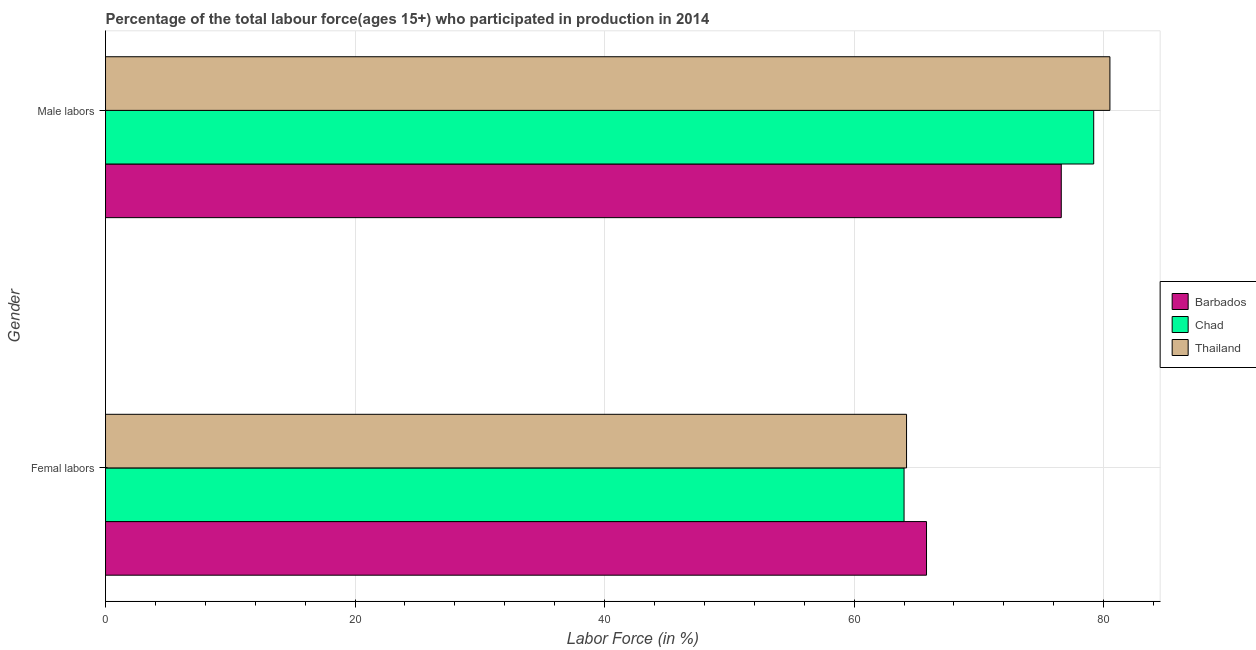How many groups of bars are there?
Your response must be concise. 2. Are the number of bars per tick equal to the number of legend labels?
Your answer should be very brief. Yes. Are the number of bars on each tick of the Y-axis equal?
Give a very brief answer. Yes. What is the label of the 1st group of bars from the top?
Your answer should be compact. Male labors. What is the percentage of male labour force in Thailand?
Your answer should be compact. 80.5. Across all countries, what is the maximum percentage of male labour force?
Give a very brief answer. 80.5. Across all countries, what is the minimum percentage of male labour force?
Keep it short and to the point. 76.6. In which country was the percentage of female labor force maximum?
Provide a succinct answer. Barbados. In which country was the percentage of female labor force minimum?
Keep it short and to the point. Chad. What is the total percentage of female labor force in the graph?
Your response must be concise. 194. What is the difference between the percentage of female labor force in Thailand and that in Barbados?
Ensure brevity in your answer.  -1.6. What is the difference between the percentage of female labor force in Chad and the percentage of male labour force in Barbados?
Your answer should be compact. -12.6. What is the average percentage of male labour force per country?
Your response must be concise. 78.77. What is the difference between the percentage of male labour force and percentage of female labor force in Barbados?
Provide a short and direct response. 10.8. In how many countries, is the percentage of male labour force greater than 76 %?
Give a very brief answer. 3. What is the ratio of the percentage of female labor force in Thailand to that in Chad?
Provide a short and direct response. 1. In how many countries, is the percentage of male labour force greater than the average percentage of male labour force taken over all countries?
Your response must be concise. 2. What does the 2nd bar from the top in Femal labors represents?
Offer a terse response. Chad. What does the 3rd bar from the bottom in Femal labors represents?
Make the answer very short. Thailand. How many bars are there?
Keep it short and to the point. 6. Are all the bars in the graph horizontal?
Make the answer very short. Yes. Are the values on the major ticks of X-axis written in scientific E-notation?
Your answer should be compact. No. How many legend labels are there?
Make the answer very short. 3. What is the title of the graph?
Provide a short and direct response. Percentage of the total labour force(ages 15+) who participated in production in 2014. Does "Panama" appear as one of the legend labels in the graph?
Offer a very short reply. No. What is the label or title of the Y-axis?
Provide a short and direct response. Gender. What is the Labor Force (in %) in Barbados in Femal labors?
Provide a succinct answer. 65.8. What is the Labor Force (in %) in Thailand in Femal labors?
Offer a very short reply. 64.2. What is the Labor Force (in %) in Barbados in Male labors?
Offer a terse response. 76.6. What is the Labor Force (in %) of Chad in Male labors?
Offer a terse response. 79.2. What is the Labor Force (in %) in Thailand in Male labors?
Offer a very short reply. 80.5. Across all Gender, what is the maximum Labor Force (in %) in Barbados?
Your answer should be compact. 76.6. Across all Gender, what is the maximum Labor Force (in %) of Chad?
Offer a very short reply. 79.2. Across all Gender, what is the maximum Labor Force (in %) in Thailand?
Ensure brevity in your answer.  80.5. Across all Gender, what is the minimum Labor Force (in %) of Barbados?
Your answer should be compact. 65.8. Across all Gender, what is the minimum Labor Force (in %) of Thailand?
Provide a short and direct response. 64.2. What is the total Labor Force (in %) in Barbados in the graph?
Provide a succinct answer. 142.4. What is the total Labor Force (in %) of Chad in the graph?
Give a very brief answer. 143.2. What is the total Labor Force (in %) in Thailand in the graph?
Ensure brevity in your answer.  144.7. What is the difference between the Labor Force (in %) of Barbados in Femal labors and that in Male labors?
Your answer should be compact. -10.8. What is the difference between the Labor Force (in %) of Chad in Femal labors and that in Male labors?
Provide a short and direct response. -15.2. What is the difference between the Labor Force (in %) of Thailand in Femal labors and that in Male labors?
Offer a terse response. -16.3. What is the difference between the Labor Force (in %) of Barbados in Femal labors and the Labor Force (in %) of Thailand in Male labors?
Give a very brief answer. -14.7. What is the difference between the Labor Force (in %) of Chad in Femal labors and the Labor Force (in %) of Thailand in Male labors?
Your answer should be compact. -16.5. What is the average Labor Force (in %) of Barbados per Gender?
Your answer should be very brief. 71.2. What is the average Labor Force (in %) in Chad per Gender?
Offer a very short reply. 71.6. What is the average Labor Force (in %) of Thailand per Gender?
Keep it short and to the point. 72.35. What is the difference between the Labor Force (in %) in Barbados and Labor Force (in %) in Chad in Femal labors?
Provide a short and direct response. 1.8. What is the difference between the Labor Force (in %) in Chad and Labor Force (in %) in Thailand in Femal labors?
Ensure brevity in your answer.  -0.2. What is the difference between the Labor Force (in %) of Barbados and Labor Force (in %) of Thailand in Male labors?
Your answer should be compact. -3.9. What is the difference between the Labor Force (in %) in Chad and Labor Force (in %) in Thailand in Male labors?
Keep it short and to the point. -1.3. What is the ratio of the Labor Force (in %) of Barbados in Femal labors to that in Male labors?
Provide a succinct answer. 0.86. What is the ratio of the Labor Force (in %) in Chad in Femal labors to that in Male labors?
Make the answer very short. 0.81. What is the ratio of the Labor Force (in %) of Thailand in Femal labors to that in Male labors?
Provide a short and direct response. 0.8. What is the difference between the highest and the second highest Labor Force (in %) in Barbados?
Give a very brief answer. 10.8. What is the difference between the highest and the second highest Labor Force (in %) in Chad?
Provide a short and direct response. 15.2. What is the difference between the highest and the lowest Labor Force (in %) of Chad?
Your answer should be compact. 15.2. What is the difference between the highest and the lowest Labor Force (in %) in Thailand?
Offer a terse response. 16.3. 